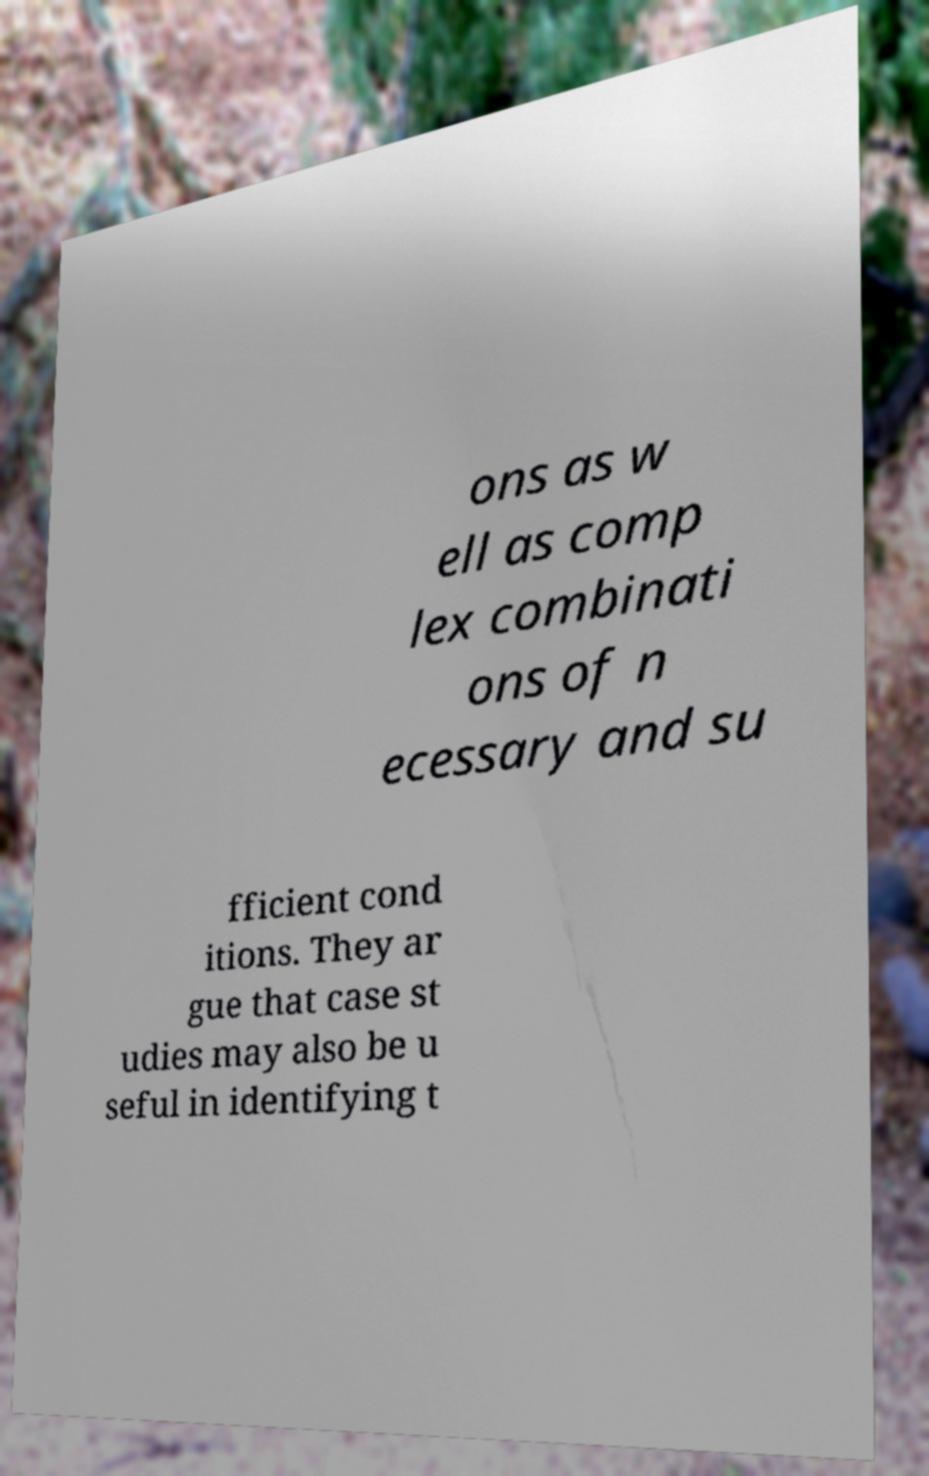Please read and relay the text visible in this image. What does it say? ons as w ell as comp lex combinati ons of n ecessary and su fficient cond itions. They ar gue that case st udies may also be u seful in identifying t 